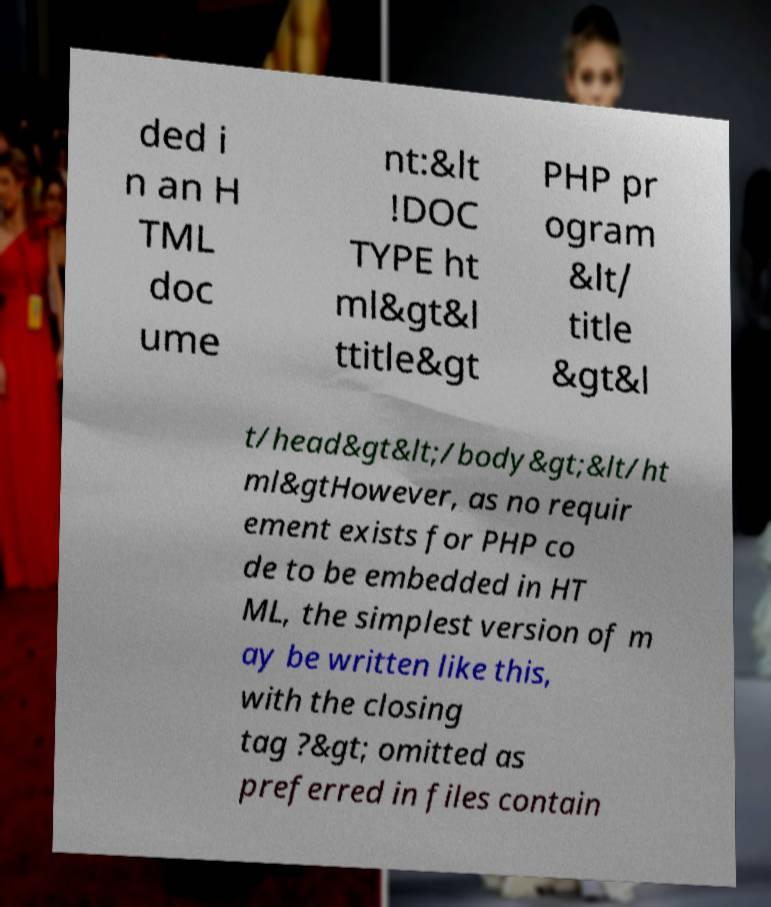Please identify and transcribe the text found in this image. ded i n an H TML doc ume nt:&lt !DOC TYPE ht ml&gt&l ttitle&gt PHP pr ogram &lt/ title &gt&l t/head&gt&lt;/body&gt;&lt/ht ml&gtHowever, as no requir ement exists for PHP co de to be embedded in HT ML, the simplest version of m ay be written like this, with the closing tag ?&gt; omitted as preferred in files contain 